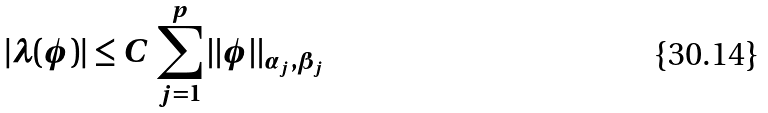<formula> <loc_0><loc_0><loc_500><loc_500>| \lambda ( \phi ) | \leq C \, \sum _ { j = 1 } ^ { p } \| \phi \| _ { \alpha _ { j } , \beta _ { j } }</formula> 